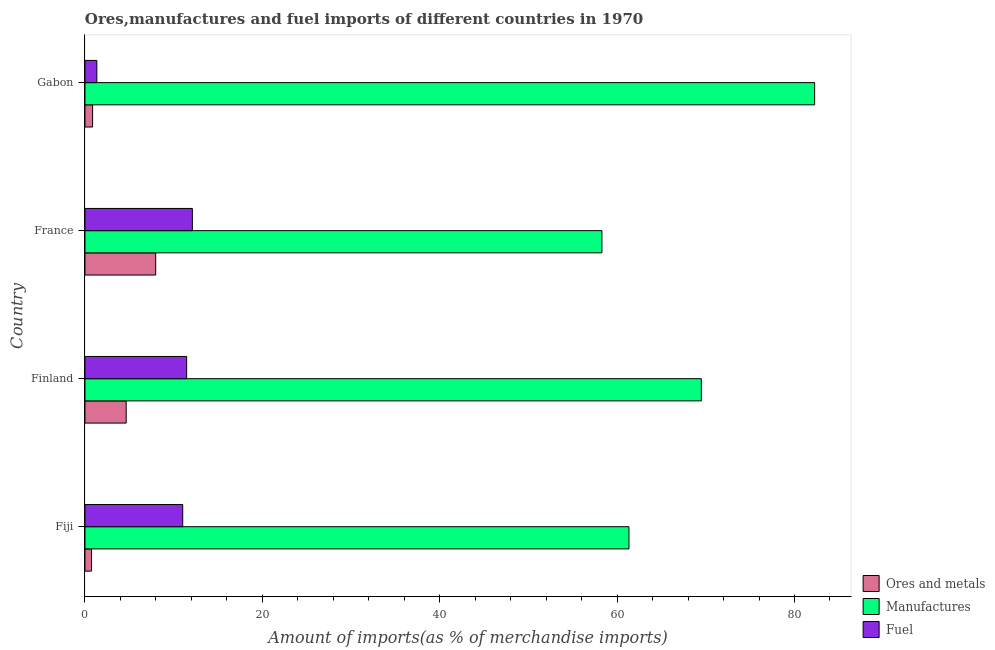How many different coloured bars are there?
Give a very brief answer. 3. How many groups of bars are there?
Keep it short and to the point. 4. Are the number of bars on each tick of the Y-axis equal?
Your answer should be compact. Yes. What is the label of the 4th group of bars from the top?
Keep it short and to the point. Fiji. What is the percentage of ores and metals imports in Fiji?
Offer a terse response. 0.74. Across all countries, what is the maximum percentage of fuel imports?
Provide a short and direct response. 12.11. Across all countries, what is the minimum percentage of fuel imports?
Offer a terse response. 1.34. In which country was the percentage of manufactures imports minimum?
Keep it short and to the point. France. What is the total percentage of manufactures imports in the graph?
Your answer should be very brief. 271.39. What is the difference between the percentage of fuel imports in France and that in Gabon?
Provide a succinct answer. 10.77. What is the difference between the percentage of ores and metals imports in Finland and the percentage of fuel imports in Gabon?
Make the answer very short. 3.31. What is the average percentage of ores and metals imports per country?
Keep it short and to the point. 3.56. What is the difference between the percentage of manufactures imports and percentage of ores and metals imports in Finland?
Ensure brevity in your answer.  64.85. Is the percentage of manufactures imports in Finland less than that in France?
Ensure brevity in your answer.  No. Is the difference between the percentage of manufactures imports in Fiji and Gabon greater than the difference between the percentage of fuel imports in Fiji and Gabon?
Your answer should be very brief. No. What is the difference between the highest and the second highest percentage of ores and metals imports?
Ensure brevity in your answer.  3.33. What is the difference between the highest and the lowest percentage of fuel imports?
Give a very brief answer. 10.77. Is the sum of the percentage of ores and metals imports in Fiji and France greater than the maximum percentage of fuel imports across all countries?
Keep it short and to the point. No. What does the 3rd bar from the top in Finland represents?
Make the answer very short. Ores and metals. What does the 3rd bar from the bottom in Fiji represents?
Provide a succinct answer. Fuel. Is it the case that in every country, the sum of the percentage of ores and metals imports and percentage of manufactures imports is greater than the percentage of fuel imports?
Keep it short and to the point. Yes. Are all the bars in the graph horizontal?
Ensure brevity in your answer.  Yes. How many countries are there in the graph?
Offer a very short reply. 4. Are the values on the major ticks of X-axis written in scientific E-notation?
Provide a short and direct response. No. Does the graph contain any zero values?
Provide a succinct answer. No. How many legend labels are there?
Your response must be concise. 3. How are the legend labels stacked?
Offer a very short reply. Vertical. What is the title of the graph?
Offer a terse response. Ores,manufactures and fuel imports of different countries in 1970. What is the label or title of the X-axis?
Make the answer very short. Amount of imports(as % of merchandise imports). What is the Amount of imports(as % of merchandise imports) in Ores and metals in Fiji?
Your answer should be very brief. 0.74. What is the Amount of imports(as % of merchandise imports) in Manufactures in Fiji?
Your answer should be compact. 61.34. What is the Amount of imports(as % of merchandise imports) of Fuel in Fiji?
Offer a very short reply. 11.02. What is the Amount of imports(as % of merchandise imports) of Ores and metals in Finland?
Make the answer very short. 4.65. What is the Amount of imports(as % of merchandise imports) of Manufactures in Finland?
Give a very brief answer. 69.5. What is the Amount of imports(as % of merchandise imports) of Fuel in Finland?
Offer a very short reply. 11.46. What is the Amount of imports(as % of merchandise imports) of Ores and metals in France?
Your answer should be compact. 7.98. What is the Amount of imports(as % of merchandise imports) in Manufactures in France?
Make the answer very short. 58.29. What is the Amount of imports(as % of merchandise imports) of Fuel in France?
Ensure brevity in your answer.  12.11. What is the Amount of imports(as % of merchandise imports) in Ores and metals in Gabon?
Make the answer very short. 0.86. What is the Amount of imports(as % of merchandise imports) of Manufactures in Gabon?
Provide a short and direct response. 82.27. What is the Amount of imports(as % of merchandise imports) in Fuel in Gabon?
Your answer should be very brief. 1.34. Across all countries, what is the maximum Amount of imports(as % of merchandise imports) of Ores and metals?
Ensure brevity in your answer.  7.98. Across all countries, what is the maximum Amount of imports(as % of merchandise imports) in Manufactures?
Provide a short and direct response. 82.27. Across all countries, what is the maximum Amount of imports(as % of merchandise imports) of Fuel?
Your answer should be very brief. 12.11. Across all countries, what is the minimum Amount of imports(as % of merchandise imports) of Ores and metals?
Your answer should be compact. 0.74. Across all countries, what is the minimum Amount of imports(as % of merchandise imports) in Manufactures?
Ensure brevity in your answer.  58.29. Across all countries, what is the minimum Amount of imports(as % of merchandise imports) in Fuel?
Make the answer very short. 1.34. What is the total Amount of imports(as % of merchandise imports) of Ores and metals in the graph?
Offer a very short reply. 14.22. What is the total Amount of imports(as % of merchandise imports) in Manufactures in the graph?
Offer a very short reply. 271.39. What is the total Amount of imports(as % of merchandise imports) in Fuel in the graph?
Make the answer very short. 35.93. What is the difference between the Amount of imports(as % of merchandise imports) of Ores and metals in Fiji and that in Finland?
Your answer should be compact. -3.91. What is the difference between the Amount of imports(as % of merchandise imports) of Manufactures in Fiji and that in Finland?
Your answer should be very brief. -8.16. What is the difference between the Amount of imports(as % of merchandise imports) in Fuel in Fiji and that in Finland?
Provide a short and direct response. -0.44. What is the difference between the Amount of imports(as % of merchandise imports) in Ores and metals in Fiji and that in France?
Your response must be concise. -7.24. What is the difference between the Amount of imports(as % of merchandise imports) in Manufactures in Fiji and that in France?
Your answer should be compact. 3.05. What is the difference between the Amount of imports(as % of merchandise imports) in Fuel in Fiji and that in France?
Keep it short and to the point. -1.09. What is the difference between the Amount of imports(as % of merchandise imports) in Ores and metals in Fiji and that in Gabon?
Give a very brief answer. -0.12. What is the difference between the Amount of imports(as % of merchandise imports) in Manufactures in Fiji and that in Gabon?
Your answer should be very brief. -20.94. What is the difference between the Amount of imports(as % of merchandise imports) of Fuel in Fiji and that in Gabon?
Make the answer very short. 9.69. What is the difference between the Amount of imports(as % of merchandise imports) of Ores and metals in Finland and that in France?
Provide a short and direct response. -3.33. What is the difference between the Amount of imports(as % of merchandise imports) in Manufactures in Finland and that in France?
Give a very brief answer. 11.21. What is the difference between the Amount of imports(as % of merchandise imports) in Fuel in Finland and that in France?
Your response must be concise. -0.65. What is the difference between the Amount of imports(as % of merchandise imports) of Ores and metals in Finland and that in Gabon?
Provide a short and direct response. 3.79. What is the difference between the Amount of imports(as % of merchandise imports) of Manufactures in Finland and that in Gabon?
Offer a very short reply. -12.77. What is the difference between the Amount of imports(as % of merchandise imports) of Fuel in Finland and that in Gabon?
Provide a short and direct response. 10.13. What is the difference between the Amount of imports(as % of merchandise imports) of Ores and metals in France and that in Gabon?
Keep it short and to the point. 7.11. What is the difference between the Amount of imports(as % of merchandise imports) in Manufactures in France and that in Gabon?
Ensure brevity in your answer.  -23.98. What is the difference between the Amount of imports(as % of merchandise imports) of Fuel in France and that in Gabon?
Ensure brevity in your answer.  10.77. What is the difference between the Amount of imports(as % of merchandise imports) in Ores and metals in Fiji and the Amount of imports(as % of merchandise imports) in Manufactures in Finland?
Your response must be concise. -68.76. What is the difference between the Amount of imports(as % of merchandise imports) of Ores and metals in Fiji and the Amount of imports(as % of merchandise imports) of Fuel in Finland?
Provide a short and direct response. -10.72. What is the difference between the Amount of imports(as % of merchandise imports) of Manufactures in Fiji and the Amount of imports(as % of merchandise imports) of Fuel in Finland?
Make the answer very short. 49.87. What is the difference between the Amount of imports(as % of merchandise imports) in Ores and metals in Fiji and the Amount of imports(as % of merchandise imports) in Manufactures in France?
Your answer should be very brief. -57.55. What is the difference between the Amount of imports(as % of merchandise imports) of Ores and metals in Fiji and the Amount of imports(as % of merchandise imports) of Fuel in France?
Make the answer very short. -11.37. What is the difference between the Amount of imports(as % of merchandise imports) in Manufactures in Fiji and the Amount of imports(as % of merchandise imports) in Fuel in France?
Your response must be concise. 49.23. What is the difference between the Amount of imports(as % of merchandise imports) of Ores and metals in Fiji and the Amount of imports(as % of merchandise imports) of Manufactures in Gabon?
Give a very brief answer. -81.53. What is the difference between the Amount of imports(as % of merchandise imports) in Ores and metals in Fiji and the Amount of imports(as % of merchandise imports) in Fuel in Gabon?
Your response must be concise. -0.6. What is the difference between the Amount of imports(as % of merchandise imports) of Manufactures in Fiji and the Amount of imports(as % of merchandise imports) of Fuel in Gabon?
Your answer should be very brief. 60. What is the difference between the Amount of imports(as % of merchandise imports) in Ores and metals in Finland and the Amount of imports(as % of merchandise imports) in Manufactures in France?
Your answer should be very brief. -53.64. What is the difference between the Amount of imports(as % of merchandise imports) of Ores and metals in Finland and the Amount of imports(as % of merchandise imports) of Fuel in France?
Your response must be concise. -7.46. What is the difference between the Amount of imports(as % of merchandise imports) of Manufactures in Finland and the Amount of imports(as % of merchandise imports) of Fuel in France?
Provide a short and direct response. 57.39. What is the difference between the Amount of imports(as % of merchandise imports) of Ores and metals in Finland and the Amount of imports(as % of merchandise imports) of Manufactures in Gabon?
Your response must be concise. -77.62. What is the difference between the Amount of imports(as % of merchandise imports) of Ores and metals in Finland and the Amount of imports(as % of merchandise imports) of Fuel in Gabon?
Make the answer very short. 3.31. What is the difference between the Amount of imports(as % of merchandise imports) in Manufactures in Finland and the Amount of imports(as % of merchandise imports) in Fuel in Gabon?
Ensure brevity in your answer.  68.16. What is the difference between the Amount of imports(as % of merchandise imports) in Ores and metals in France and the Amount of imports(as % of merchandise imports) in Manufactures in Gabon?
Ensure brevity in your answer.  -74.3. What is the difference between the Amount of imports(as % of merchandise imports) in Ores and metals in France and the Amount of imports(as % of merchandise imports) in Fuel in Gabon?
Your answer should be very brief. 6.64. What is the difference between the Amount of imports(as % of merchandise imports) in Manufactures in France and the Amount of imports(as % of merchandise imports) in Fuel in Gabon?
Give a very brief answer. 56.95. What is the average Amount of imports(as % of merchandise imports) of Ores and metals per country?
Your answer should be compact. 3.56. What is the average Amount of imports(as % of merchandise imports) in Manufactures per country?
Your answer should be compact. 67.85. What is the average Amount of imports(as % of merchandise imports) in Fuel per country?
Offer a very short reply. 8.98. What is the difference between the Amount of imports(as % of merchandise imports) in Ores and metals and Amount of imports(as % of merchandise imports) in Manufactures in Fiji?
Keep it short and to the point. -60.6. What is the difference between the Amount of imports(as % of merchandise imports) of Ores and metals and Amount of imports(as % of merchandise imports) of Fuel in Fiji?
Make the answer very short. -10.28. What is the difference between the Amount of imports(as % of merchandise imports) of Manufactures and Amount of imports(as % of merchandise imports) of Fuel in Fiji?
Your answer should be compact. 50.31. What is the difference between the Amount of imports(as % of merchandise imports) of Ores and metals and Amount of imports(as % of merchandise imports) of Manufactures in Finland?
Your answer should be very brief. -64.85. What is the difference between the Amount of imports(as % of merchandise imports) of Ores and metals and Amount of imports(as % of merchandise imports) of Fuel in Finland?
Make the answer very short. -6.82. What is the difference between the Amount of imports(as % of merchandise imports) of Manufactures and Amount of imports(as % of merchandise imports) of Fuel in Finland?
Ensure brevity in your answer.  58.03. What is the difference between the Amount of imports(as % of merchandise imports) of Ores and metals and Amount of imports(as % of merchandise imports) of Manufactures in France?
Your response must be concise. -50.31. What is the difference between the Amount of imports(as % of merchandise imports) of Ores and metals and Amount of imports(as % of merchandise imports) of Fuel in France?
Your response must be concise. -4.13. What is the difference between the Amount of imports(as % of merchandise imports) in Manufactures and Amount of imports(as % of merchandise imports) in Fuel in France?
Provide a short and direct response. 46.18. What is the difference between the Amount of imports(as % of merchandise imports) in Ores and metals and Amount of imports(as % of merchandise imports) in Manufactures in Gabon?
Make the answer very short. -81.41. What is the difference between the Amount of imports(as % of merchandise imports) in Ores and metals and Amount of imports(as % of merchandise imports) in Fuel in Gabon?
Offer a very short reply. -0.48. What is the difference between the Amount of imports(as % of merchandise imports) in Manufactures and Amount of imports(as % of merchandise imports) in Fuel in Gabon?
Your answer should be compact. 80.93. What is the ratio of the Amount of imports(as % of merchandise imports) in Ores and metals in Fiji to that in Finland?
Keep it short and to the point. 0.16. What is the ratio of the Amount of imports(as % of merchandise imports) of Manufactures in Fiji to that in Finland?
Give a very brief answer. 0.88. What is the ratio of the Amount of imports(as % of merchandise imports) in Fuel in Fiji to that in Finland?
Offer a terse response. 0.96. What is the ratio of the Amount of imports(as % of merchandise imports) in Ores and metals in Fiji to that in France?
Offer a terse response. 0.09. What is the ratio of the Amount of imports(as % of merchandise imports) in Manufactures in Fiji to that in France?
Make the answer very short. 1.05. What is the ratio of the Amount of imports(as % of merchandise imports) in Fuel in Fiji to that in France?
Your answer should be compact. 0.91. What is the ratio of the Amount of imports(as % of merchandise imports) of Ores and metals in Fiji to that in Gabon?
Provide a succinct answer. 0.86. What is the ratio of the Amount of imports(as % of merchandise imports) of Manufactures in Fiji to that in Gabon?
Keep it short and to the point. 0.75. What is the ratio of the Amount of imports(as % of merchandise imports) of Fuel in Fiji to that in Gabon?
Give a very brief answer. 8.24. What is the ratio of the Amount of imports(as % of merchandise imports) in Ores and metals in Finland to that in France?
Offer a terse response. 0.58. What is the ratio of the Amount of imports(as % of merchandise imports) in Manufactures in Finland to that in France?
Your answer should be compact. 1.19. What is the ratio of the Amount of imports(as % of merchandise imports) in Fuel in Finland to that in France?
Provide a succinct answer. 0.95. What is the ratio of the Amount of imports(as % of merchandise imports) of Ores and metals in Finland to that in Gabon?
Your answer should be very brief. 5.4. What is the ratio of the Amount of imports(as % of merchandise imports) of Manufactures in Finland to that in Gabon?
Your answer should be compact. 0.84. What is the ratio of the Amount of imports(as % of merchandise imports) of Fuel in Finland to that in Gabon?
Provide a short and direct response. 8.57. What is the ratio of the Amount of imports(as % of merchandise imports) in Ores and metals in France to that in Gabon?
Your answer should be compact. 9.27. What is the ratio of the Amount of imports(as % of merchandise imports) in Manufactures in France to that in Gabon?
Provide a short and direct response. 0.71. What is the ratio of the Amount of imports(as % of merchandise imports) of Fuel in France to that in Gabon?
Make the answer very short. 9.06. What is the difference between the highest and the second highest Amount of imports(as % of merchandise imports) in Ores and metals?
Make the answer very short. 3.33. What is the difference between the highest and the second highest Amount of imports(as % of merchandise imports) of Manufactures?
Offer a terse response. 12.77. What is the difference between the highest and the second highest Amount of imports(as % of merchandise imports) of Fuel?
Your answer should be very brief. 0.65. What is the difference between the highest and the lowest Amount of imports(as % of merchandise imports) of Ores and metals?
Your response must be concise. 7.24. What is the difference between the highest and the lowest Amount of imports(as % of merchandise imports) in Manufactures?
Make the answer very short. 23.98. What is the difference between the highest and the lowest Amount of imports(as % of merchandise imports) in Fuel?
Make the answer very short. 10.77. 